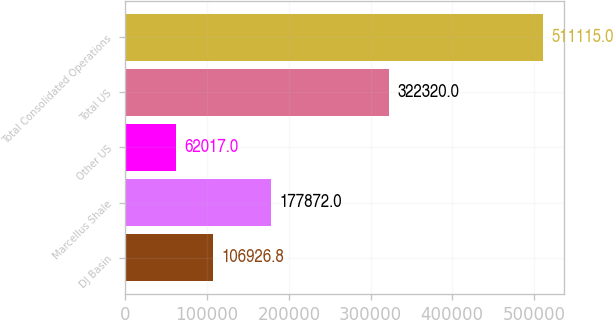Convert chart. <chart><loc_0><loc_0><loc_500><loc_500><bar_chart><fcel>DJ Basin<fcel>Marcellus Shale<fcel>Other US<fcel>Total US<fcel>Total Consolidated Operations<nl><fcel>106927<fcel>177872<fcel>62017<fcel>322320<fcel>511115<nl></chart> 